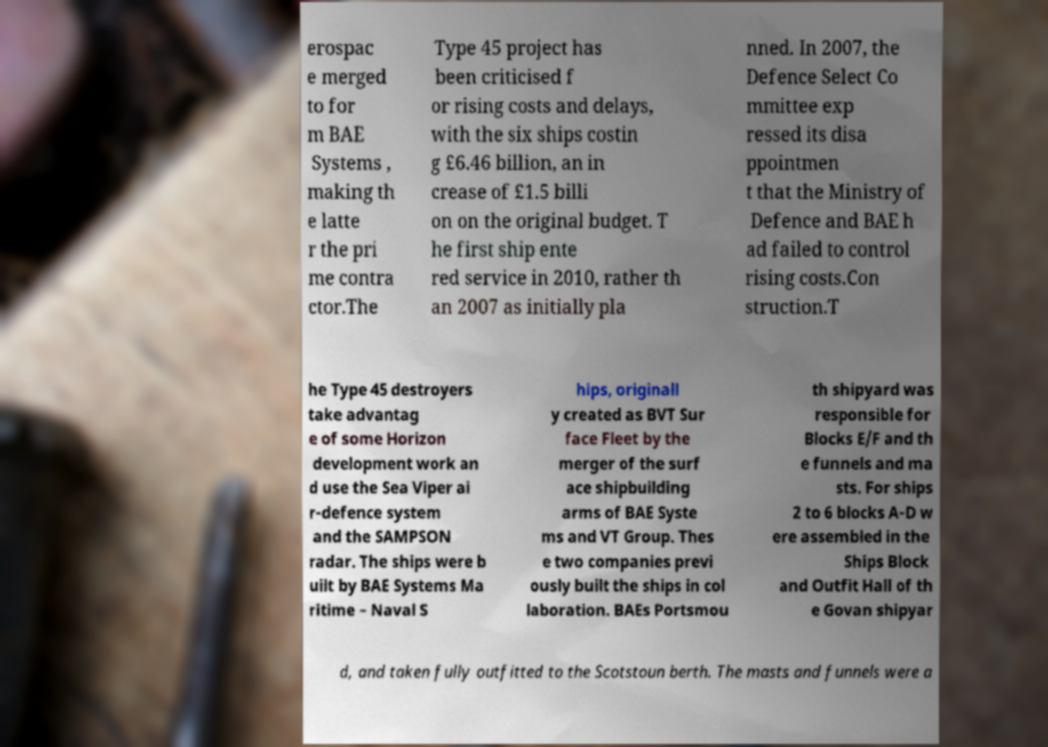What messages or text are displayed in this image? I need them in a readable, typed format. erospac e merged to for m BAE Systems , making th e latte r the pri me contra ctor.The Type 45 project has been criticised f or rising costs and delays, with the six ships costin g £6.46 billion, an in crease of £1.5 billi on on the original budget. T he first ship ente red service in 2010, rather th an 2007 as initially pla nned. In 2007, the Defence Select Co mmittee exp ressed its disa ppointmen t that the Ministry of Defence and BAE h ad failed to control rising costs.Con struction.T he Type 45 destroyers take advantag e of some Horizon development work an d use the Sea Viper ai r-defence system and the SAMPSON radar. The ships were b uilt by BAE Systems Ma ritime – Naval S hips, originall y created as BVT Sur face Fleet by the merger of the surf ace shipbuilding arms of BAE Syste ms and VT Group. Thes e two companies previ ously built the ships in col laboration. BAEs Portsmou th shipyard was responsible for Blocks E/F and th e funnels and ma sts. For ships 2 to 6 blocks A-D w ere assembled in the Ships Block and Outfit Hall of th e Govan shipyar d, and taken fully outfitted to the Scotstoun berth. The masts and funnels were a 